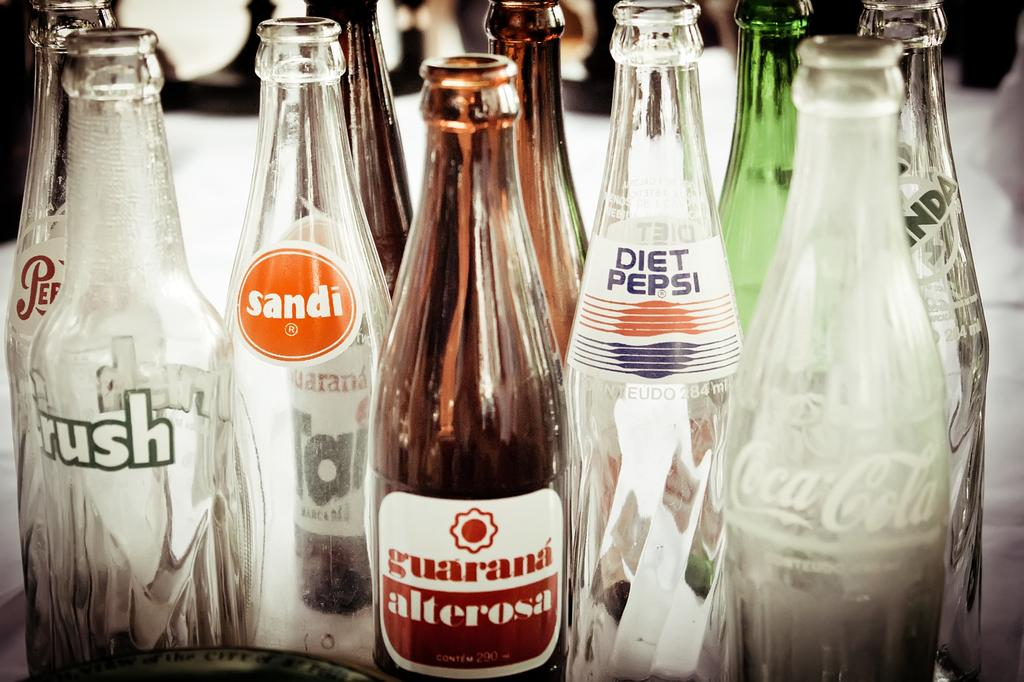What type of containers are present in the image? There are many glass bottles in the image. What can be found on the labels of the bottles? The labels have "sandi," "diet pepsi," and "coca cola" written on them. What type of berry is being picked in the image? There is no berry or any indication of picking in the image; it only shows glass bottles with labels. 